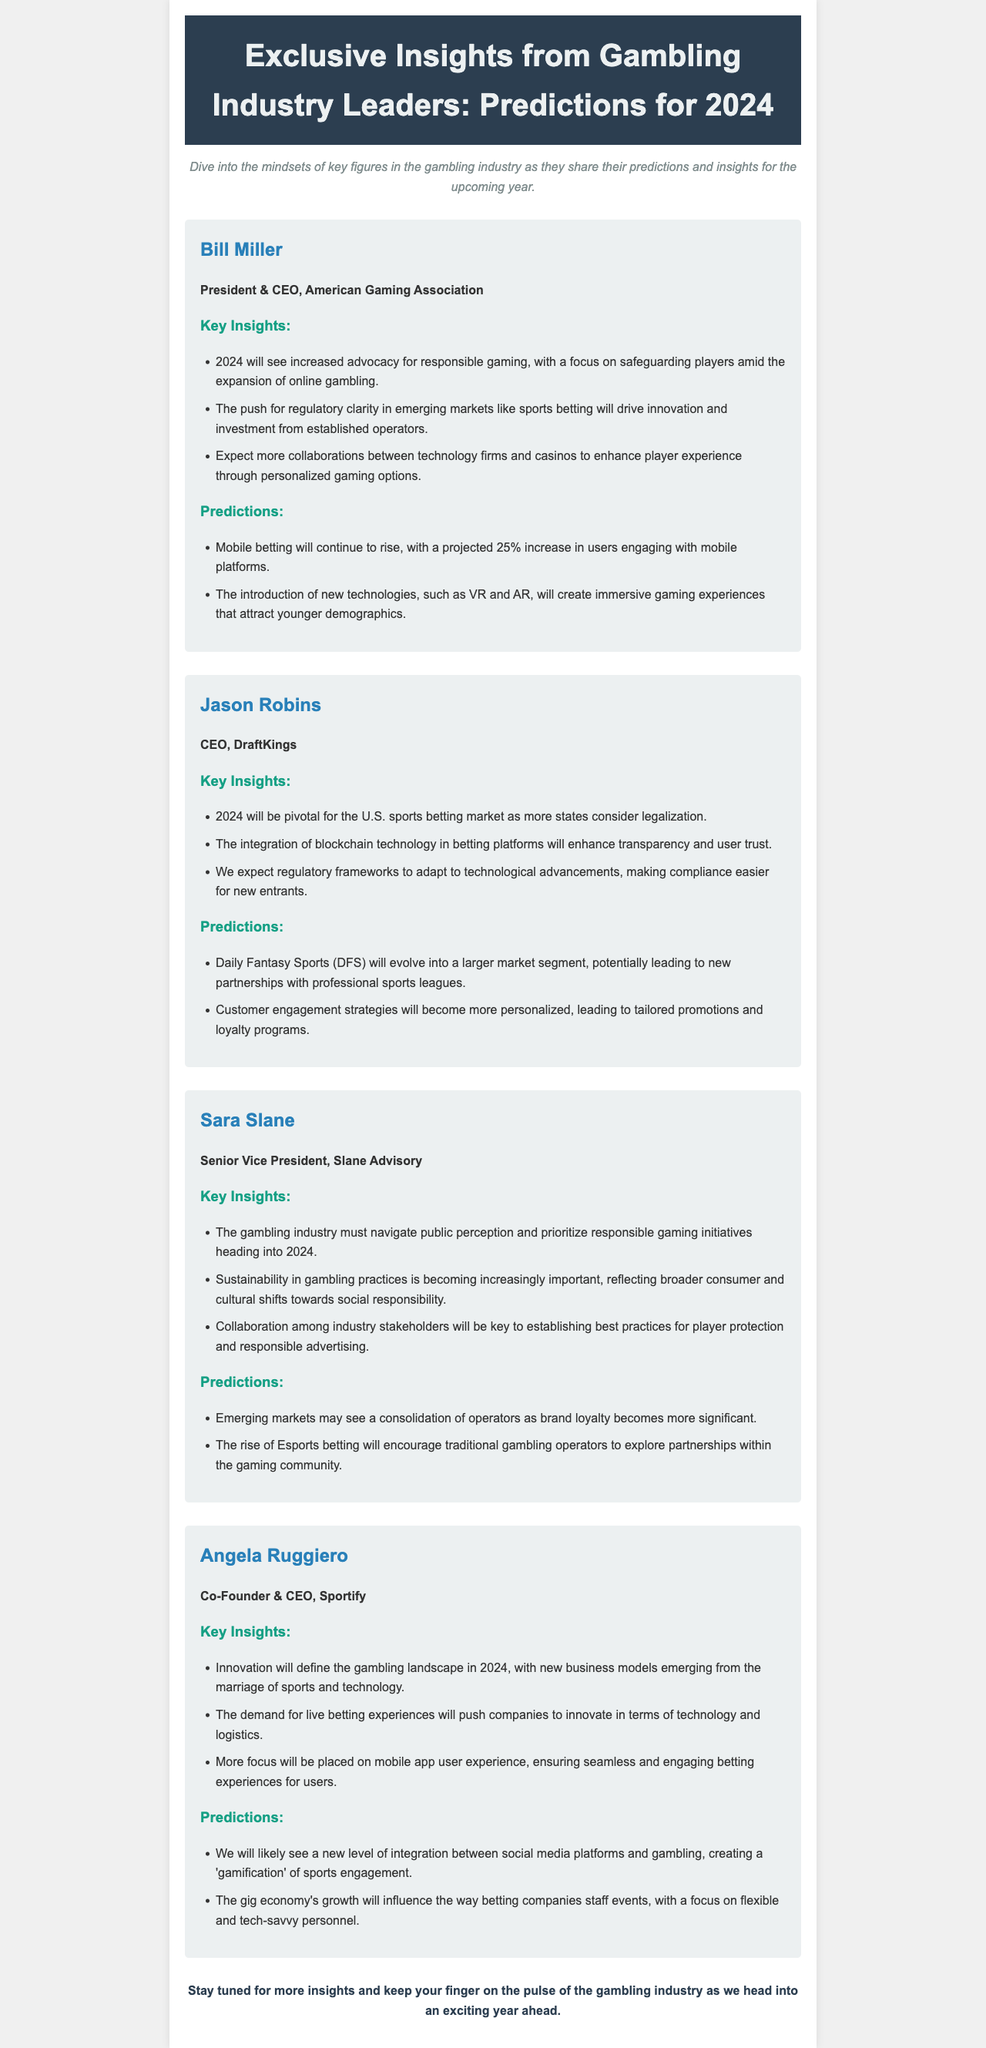What is the title of the newsletter? The title of the newsletter is prominently displayed in the header section of the document.
Answer: Exclusive Insights from Gambling Industry Leaders: Predictions for 2024 Who is the CEO of DraftKings? The document includes information about key figures in the gambling industry, referring to their roles and names.
Answer: Jason Robins What key insight is shared by Bill Miller regarding online gambling? Bill Miller's insights highlight important trends in the gambling industry, specifically regarding responsible gaming.
Answer: Increased advocacy for responsible gaming What prediction does Jason Robins make about Daily Fantasy Sports? The predictions made by industry leaders in their interviews reflect their outlook for the year's trends.
Answer: Evolve into a larger market segment Which industry figure emphasizes the importance of sustainability? Insights from various leaders point to significant industry themes, including social responsibility.
Answer: Sara Slane How much is mobile betting projected to increase in 2024 according to Bill Miller? The document specifies numerical projections concerning trends in mobile betting for the coming year.
Answer: 25% What innovative technology is expected to integrate with betting platforms? Technological advancements discussed by the leaders reflect evolving practices in the gambling industry.
Answer: Blockchain technology What will influence staffing for betting companies according to Angela Ruggiero? The insights discuss how external factors may shape company practices, particularly in staffing.
Answer: Gig economy's growth What is a significant trend that Sara Slane predicts for emerging markets? Predictions made by industry leaders showcase the anticipated developments in specific market conditions.
Answer: Consolidation of operators 